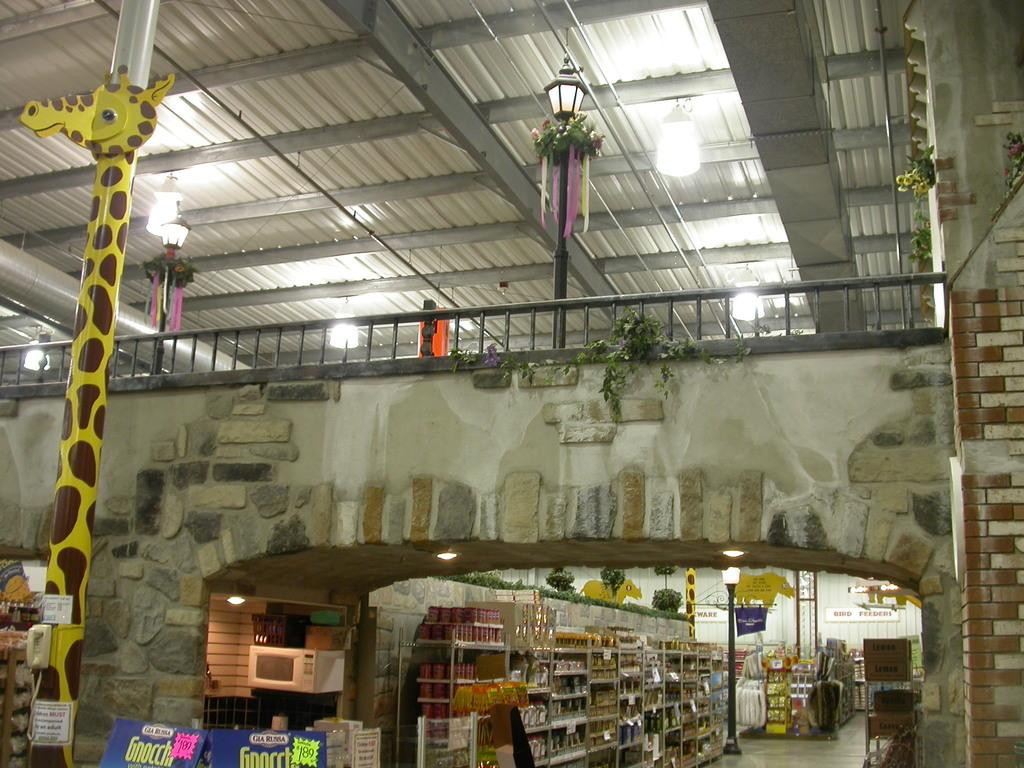What can be seen in the image in terms of structures or objects? There are many boards, poles, and a store in the image. What is inside the store? There are many objects in the store. Are there any additional features in the image? Yes, there is a railing and lights at the top in the image. How does the fire spread in the image? There is no fire present in the image. What is the increase in the number of objects in the store? The number of objects in the store is not mentioned as increasing or decreasing in the image. 